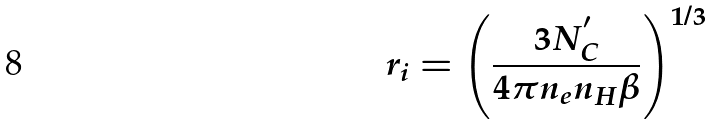<formula> <loc_0><loc_0><loc_500><loc_500>r _ { i } = \left ( \frac { 3 N _ { C } ^ { ^ { \prime } } } { 4 \pi n _ { e } n _ { H } \beta } \right ) ^ { 1 / 3 }</formula> 